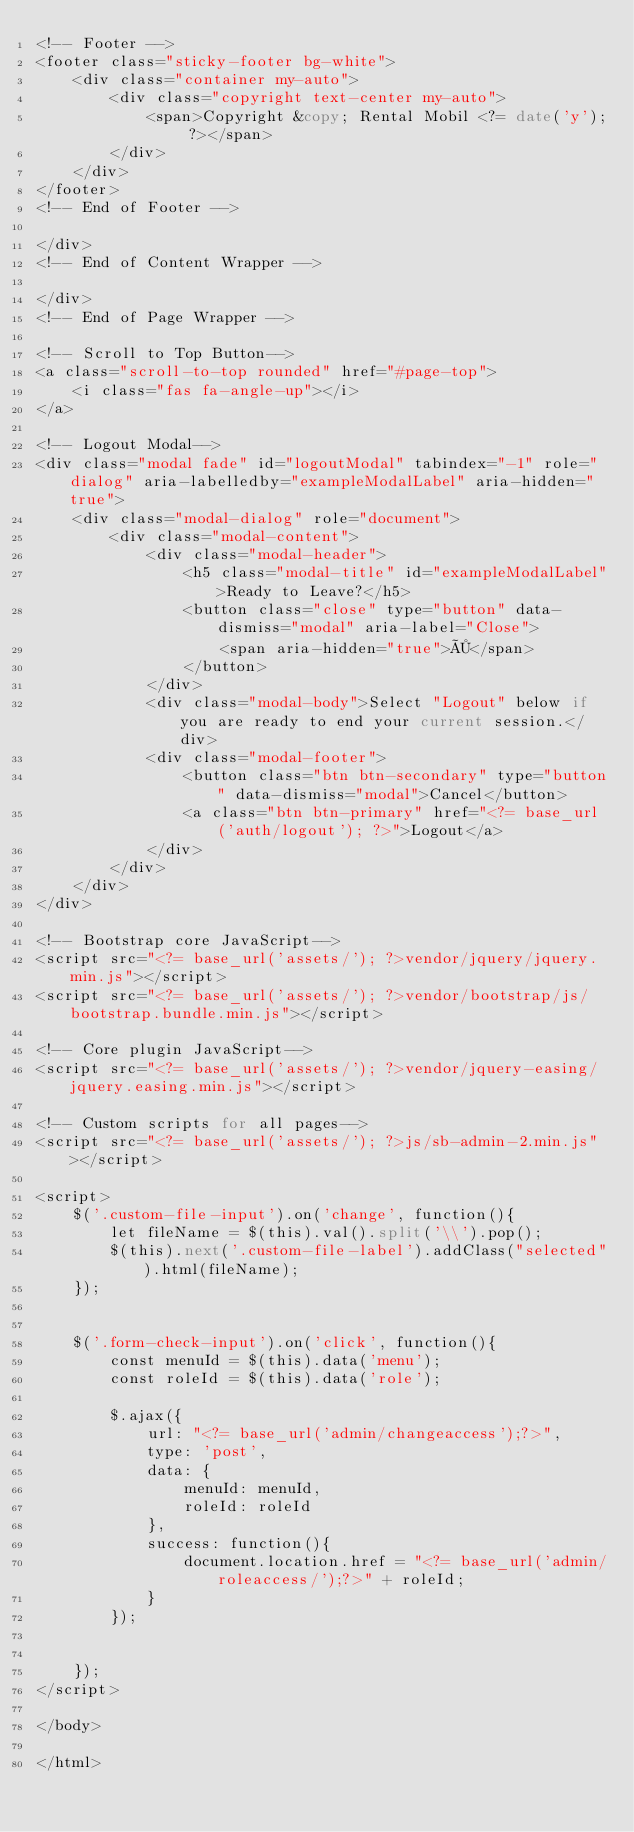<code> <loc_0><loc_0><loc_500><loc_500><_PHP_><!-- Footer -->
<footer class="sticky-footer bg-white">
    <div class="container my-auto">
        <div class="copyright text-center my-auto">
            <span>Copyright &copy; Rental Mobil <?= date('y'); ?></span>
        </div>
    </div>
</footer>
<!-- End of Footer -->

</div>
<!-- End of Content Wrapper -->

</div>
<!-- End of Page Wrapper -->

<!-- Scroll to Top Button-->
<a class="scroll-to-top rounded" href="#page-top">
    <i class="fas fa-angle-up"></i>
</a>

<!-- Logout Modal-->
<div class="modal fade" id="logoutModal" tabindex="-1" role="dialog" aria-labelledby="exampleModalLabel" aria-hidden="true">
    <div class="modal-dialog" role="document">
        <div class="modal-content">
            <div class="modal-header">
                <h5 class="modal-title" id="exampleModalLabel">Ready to Leave?</h5>
                <button class="close" type="button" data-dismiss="modal" aria-label="Close">
                    <span aria-hidden="true">×</span>
                </button>
            </div>
            <div class="modal-body">Select "Logout" below if you are ready to end your current session.</div>
            <div class="modal-footer">
                <button class="btn btn-secondary" type="button" data-dismiss="modal">Cancel</button>
                <a class="btn btn-primary" href="<?= base_url('auth/logout'); ?>">Logout</a>
            </div>
        </div>
    </div>
</div>

<!-- Bootstrap core JavaScript-->
<script src="<?= base_url('assets/'); ?>vendor/jquery/jquery.min.js"></script>
<script src="<?= base_url('assets/'); ?>vendor/bootstrap/js/bootstrap.bundle.min.js"></script>

<!-- Core plugin JavaScript-->
<script src="<?= base_url('assets/'); ?>vendor/jquery-easing/jquery.easing.min.js"></script>

<!-- Custom scripts for all pages-->
<script src="<?= base_url('assets/'); ?>js/sb-admin-2.min.js"></script>

<script>
    $('.custom-file-input').on('change', function(){
        let fileName = $(this).val().split('\\').pop();
        $(this).next('.custom-file-label').addClass("selected").html(fileName);
    });


    $('.form-check-input').on('click', function(){
        const menuId = $(this).data('menu');
        const roleId = $(this).data('role');

        $.ajax({
            url: "<?= base_url('admin/changeaccess');?>",
            type: 'post',
            data: {
                menuId: menuId,
                roleId: roleId
            },
            success: function(){
                document.location.href = "<?= base_url('admin/roleaccess/');?>" + roleId;
            }
        });


    });
</script>

</body>

</html> </code> 